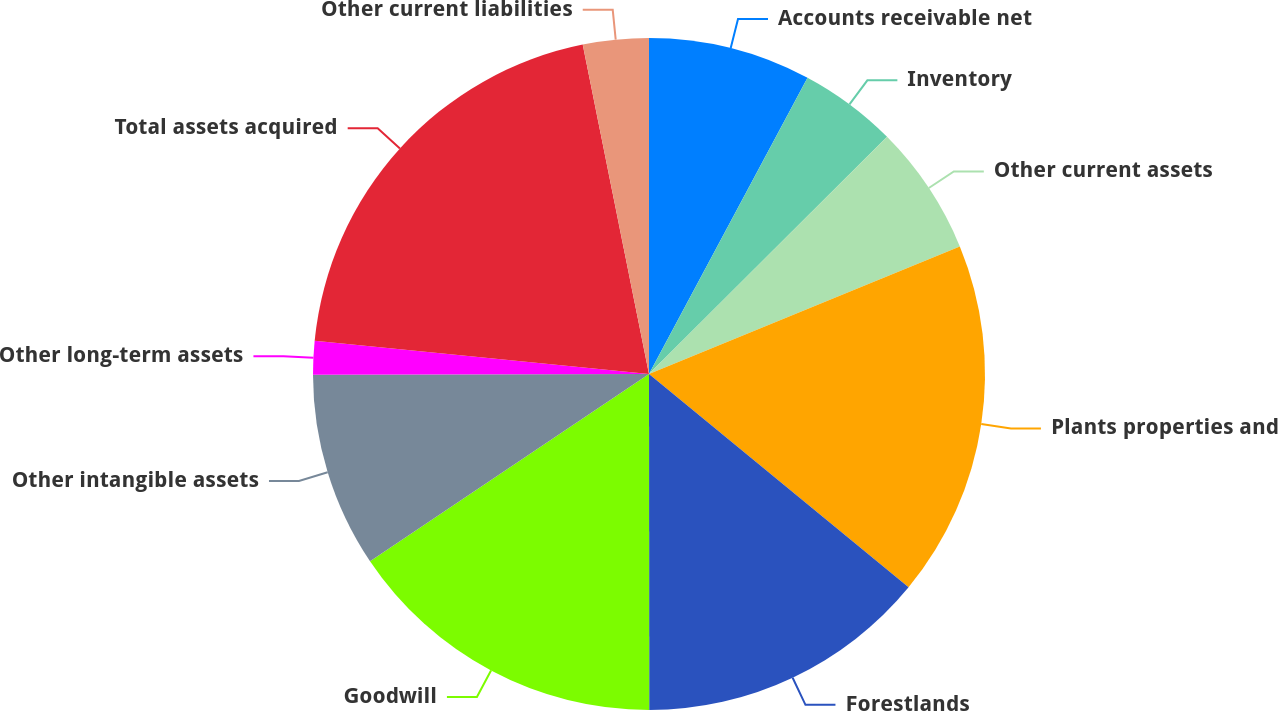<chart> <loc_0><loc_0><loc_500><loc_500><pie_chart><fcel>Accounts receivable net<fcel>Inventory<fcel>Other current assets<fcel>Plants properties and<fcel>Forestlands<fcel>Goodwill<fcel>Other intangible assets<fcel>Other long-term assets<fcel>Total assets acquired<fcel>Other current liabilities<nl><fcel>7.82%<fcel>4.71%<fcel>6.27%<fcel>17.15%<fcel>14.04%<fcel>15.6%<fcel>9.38%<fcel>1.61%<fcel>20.26%<fcel>3.16%<nl></chart> 